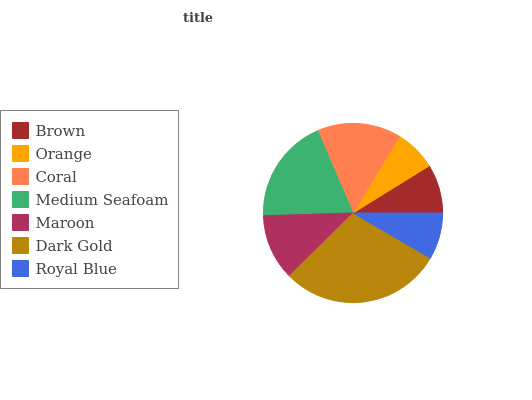Is Orange the minimum?
Answer yes or no. Yes. Is Dark Gold the maximum?
Answer yes or no. Yes. Is Coral the minimum?
Answer yes or no. No. Is Coral the maximum?
Answer yes or no. No. Is Coral greater than Orange?
Answer yes or no. Yes. Is Orange less than Coral?
Answer yes or no. Yes. Is Orange greater than Coral?
Answer yes or no. No. Is Coral less than Orange?
Answer yes or no. No. Is Maroon the high median?
Answer yes or no. Yes. Is Maroon the low median?
Answer yes or no. Yes. Is Medium Seafoam the high median?
Answer yes or no. No. Is Orange the low median?
Answer yes or no. No. 